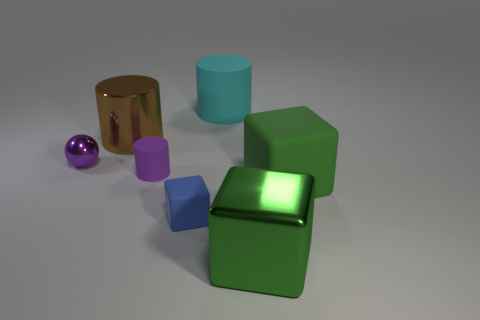Can you describe the composition of the objects in terms of balance and symmetry? The composition of objects lacks formal symmetry but has a balanced distribution. The objects are arranged with varying heights and sizes that draw the eye across the scene, with the larger green cube anchoring the arrangement centrally. The placement allows for a pleasing visual equilibrium without mirroring any one side. 